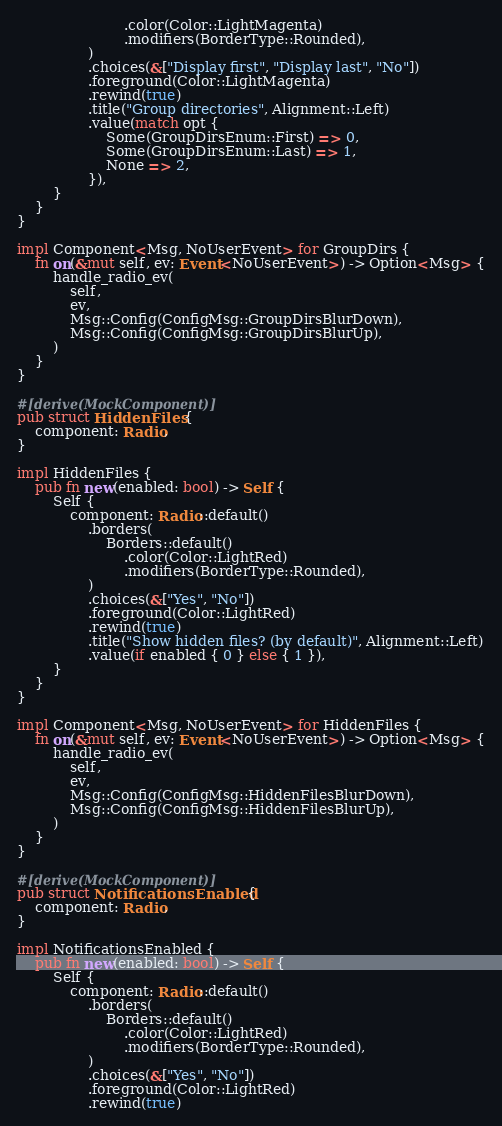<code> <loc_0><loc_0><loc_500><loc_500><_Rust_>                        .color(Color::LightMagenta)
                        .modifiers(BorderType::Rounded),
                )
                .choices(&["Display first", "Display last", "No"])
                .foreground(Color::LightMagenta)
                .rewind(true)
                .title("Group directories", Alignment::Left)
                .value(match opt {
                    Some(GroupDirsEnum::First) => 0,
                    Some(GroupDirsEnum::Last) => 1,
                    None => 2,
                }),
        }
    }
}

impl Component<Msg, NoUserEvent> for GroupDirs {
    fn on(&mut self, ev: Event<NoUserEvent>) -> Option<Msg> {
        handle_radio_ev(
            self,
            ev,
            Msg::Config(ConfigMsg::GroupDirsBlurDown),
            Msg::Config(ConfigMsg::GroupDirsBlurUp),
        )
    }
}

#[derive(MockComponent)]
pub struct HiddenFiles {
    component: Radio,
}

impl HiddenFiles {
    pub fn new(enabled: bool) -> Self {
        Self {
            component: Radio::default()
                .borders(
                    Borders::default()
                        .color(Color::LightRed)
                        .modifiers(BorderType::Rounded),
                )
                .choices(&["Yes", "No"])
                .foreground(Color::LightRed)
                .rewind(true)
                .title("Show hidden files? (by default)", Alignment::Left)
                .value(if enabled { 0 } else { 1 }),
        }
    }
}

impl Component<Msg, NoUserEvent> for HiddenFiles {
    fn on(&mut self, ev: Event<NoUserEvent>) -> Option<Msg> {
        handle_radio_ev(
            self,
            ev,
            Msg::Config(ConfigMsg::HiddenFilesBlurDown),
            Msg::Config(ConfigMsg::HiddenFilesBlurUp),
        )
    }
}

#[derive(MockComponent)]
pub struct NotificationsEnabled {
    component: Radio,
}

impl NotificationsEnabled {
    pub fn new(enabled: bool) -> Self {
        Self {
            component: Radio::default()
                .borders(
                    Borders::default()
                        .color(Color::LightRed)
                        .modifiers(BorderType::Rounded),
                )
                .choices(&["Yes", "No"])
                .foreground(Color::LightRed)
                .rewind(true)</code> 